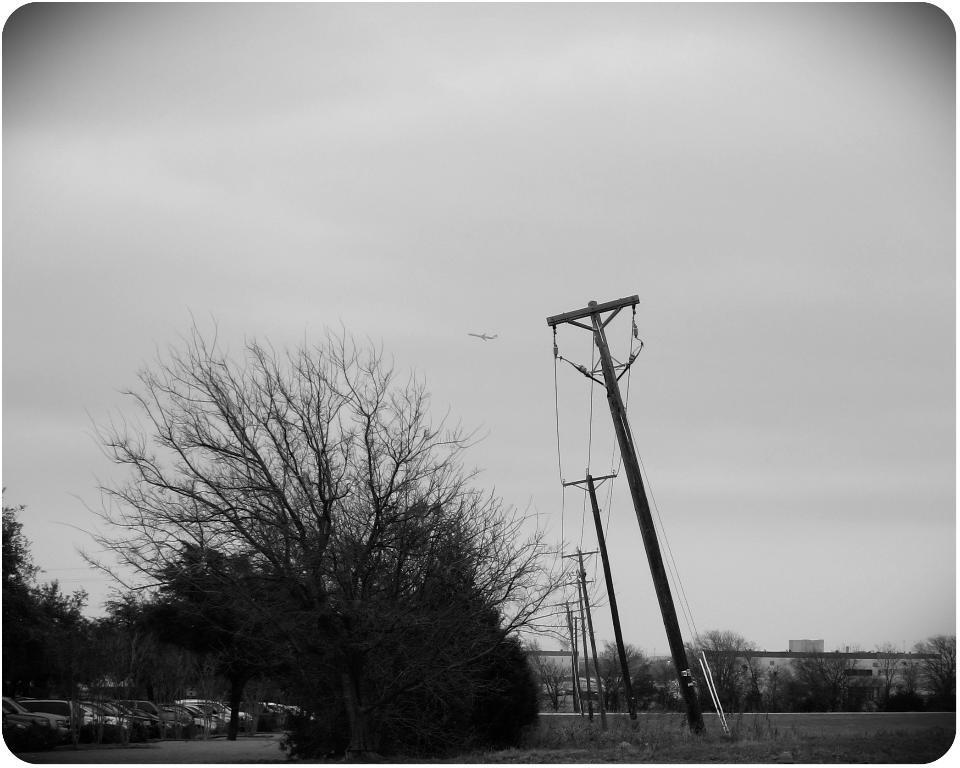In one or two sentences, can you explain what this image depicts? In this picture we can see cars on the ground, trees, poles, buildings and in the background we can see the sky. 